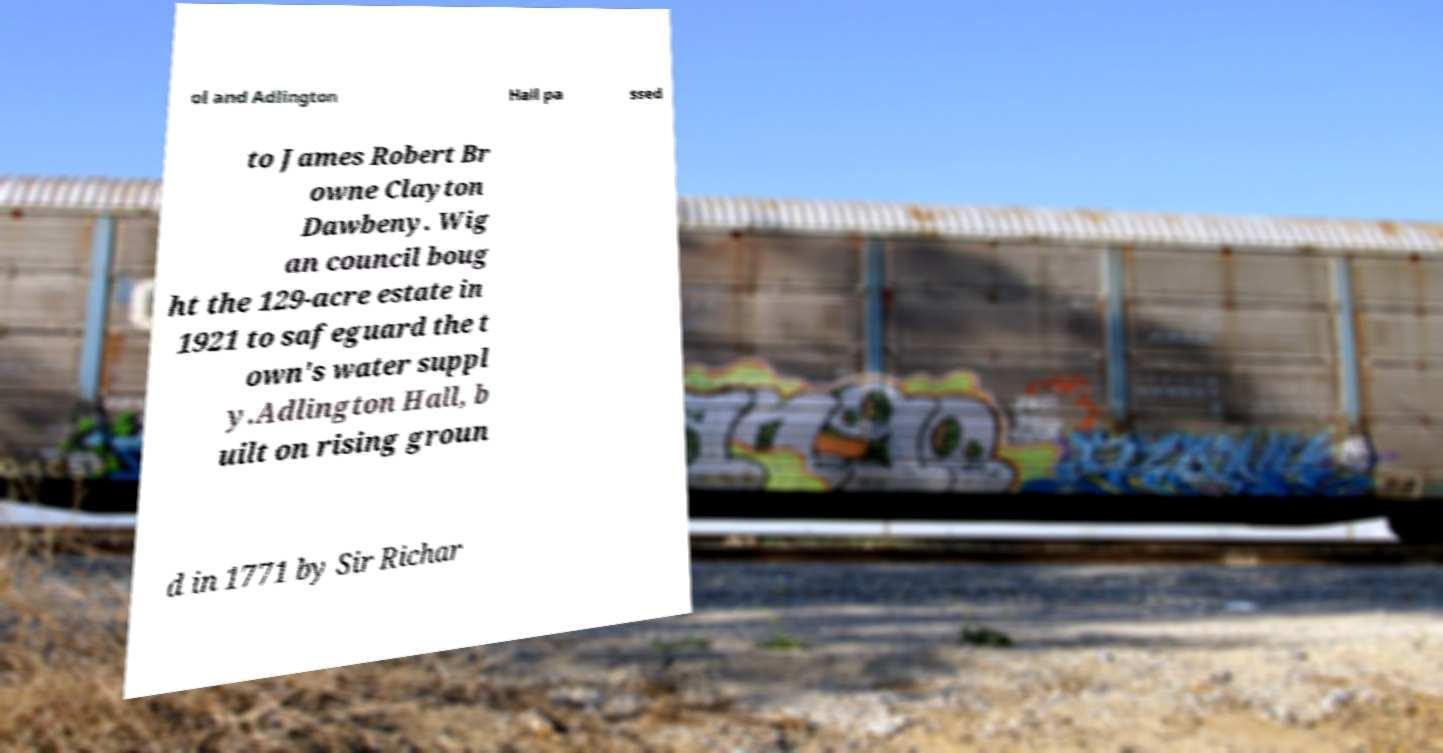Could you extract and type out the text from this image? ol and Adlington Hall pa ssed to James Robert Br owne Clayton Dawbeny. Wig an council boug ht the 129-acre estate in 1921 to safeguard the t own's water suppl y.Adlington Hall, b uilt on rising groun d in 1771 by Sir Richar 